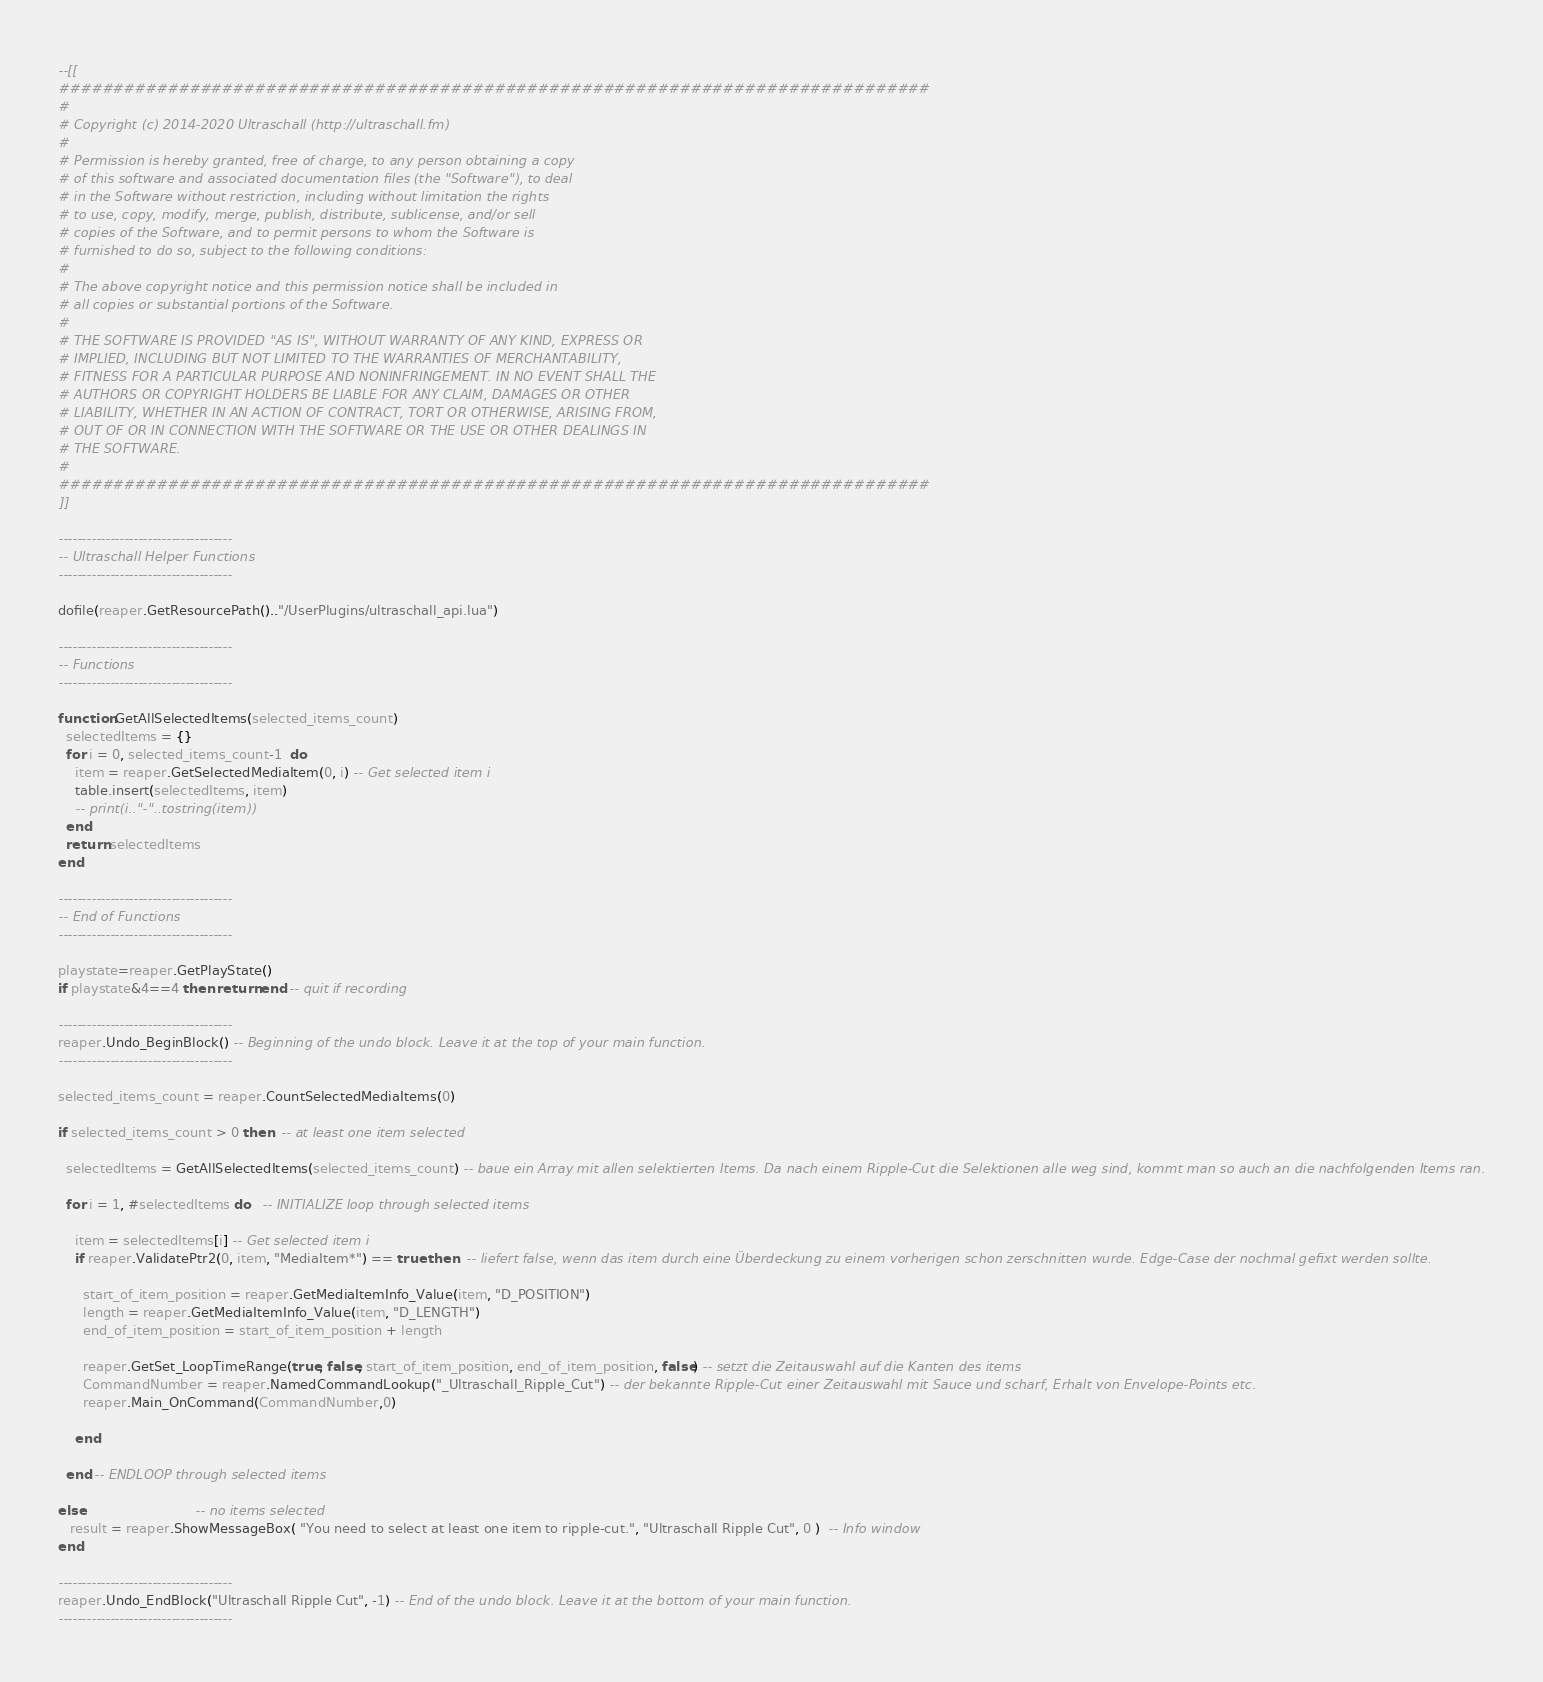Convert code to text. <code><loc_0><loc_0><loc_500><loc_500><_Lua_>--[[
################################################################################
#
# Copyright (c) 2014-2020 Ultraschall (http://ultraschall.fm)
#
# Permission is hereby granted, free of charge, to any person obtaining a copy
# of this software and associated documentation files (the "Software"), to deal
# in the Software without restriction, including without limitation the rights
# to use, copy, modify, merge, publish, distribute, sublicense, and/or sell
# copies of the Software, and to permit persons to whom the Software is
# furnished to do so, subject to the following conditions:
#
# The above copyright notice and this permission notice shall be included in
# all copies or substantial portions of the Software.
#
# THE SOFTWARE IS PROVIDED "AS IS", WITHOUT WARRANTY OF ANY KIND, EXPRESS OR
# IMPLIED, INCLUDING BUT NOT LIMITED TO THE WARRANTIES OF MERCHANTABILITY,
# FITNESS FOR A PARTICULAR PURPOSE AND NONINFRINGEMENT. IN NO EVENT SHALL THE
# AUTHORS OR COPYRIGHT HOLDERS BE LIABLE FOR ANY CLAIM, DAMAGES OR OTHER
# LIABILITY, WHETHER IN AN ACTION OF CONTRACT, TORT OR OTHERWISE, ARISING FROM,
# OUT OF OR IN CONNECTION WITH THE SOFTWARE OR THE USE OR OTHER DEALINGS IN
# THE SOFTWARE.
#
################################################################################
]]

-------------------------------------
-- Ultraschall Helper Functions
-------------------------------------

dofile(reaper.GetResourcePath().."/UserPlugins/ultraschall_api.lua")

-------------------------------------
-- Functions
-------------------------------------

function GetAllSelectedItems(selected_items_count)
  selectedItems = {}
  for i = 0, selected_items_count-1  do
    item = reaper.GetSelectedMediaItem(0, i) -- Get selected item i
    table.insert(selectedItems, item)
    -- print(i.."-"..tostring(item))
  end
  return selectedItems
end

-------------------------------------
-- End of Functions
-------------------------------------

playstate=reaper.GetPlayState()
if playstate&4==4 then return end -- quit if recording

-------------------------------------
reaper.Undo_BeginBlock() -- Beginning of the undo block. Leave it at the top of your main function.
-------------------------------------

selected_items_count = reaper.CountSelectedMediaItems(0)

if selected_items_count > 0 then  -- at least one item selected

  selectedItems = GetAllSelectedItems(selected_items_count) -- baue ein Array mit allen selektierten Items. Da nach einem Ripple-Cut die Selektionen alle weg sind, kommt man so auch an die nachfolgenden Items ran.

  for i = 1, #selectedItems do   -- INITIALIZE loop through selected items

    item = selectedItems[i] -- Get selected item i
    if reaper.ValidatePtr2(0, item, "MediaItem*") == true then  -- liefert false, wenn das item durch eine Überdeckung zu einem vorherigen schon zerschnitten wurde. Edge-Case der nochmal gefixt werden sollte.

      start_of_item_position = reaper.GetMediaItemInfo_Value(item, "D_POSITION")
      length = reaper.GetMediaItemInfo_Value(item, "D_LENGTH")
      end_of_item_position = start_of_item_position + length

      reaper.GetSet_LoopTimeRange(true, false, start_of_item_position, end_of_item_position, false) -- setzt die Zeitauswahl auf die Kanten des items
      CommandNumber = reaper.NamedCommandLookup("_Ultraschall_Ripple_Cut") -- der bekannte Ripple-Cut einer Zeitauswahl mit Sauce und scharf, Erhalt von Envelope-Points etc.
      reaper.Main_OnCommand(CommandNumber,0)

    end

  end -- ENDLOOP through selected items

else                           -- no items selected
   result = reaper.ShowMessageBox( "You need to select at least one item to ripple-cut.", "Ultraschall Ripple Cut", 0 )  -- Info window
end

-------------------------------------
reaper.Undo_EndBlock("Ultraschall Ripple Cut", -1) -- End of the undo block. Leave it at the bottom of your main function.
-------------------------------------
</code> 